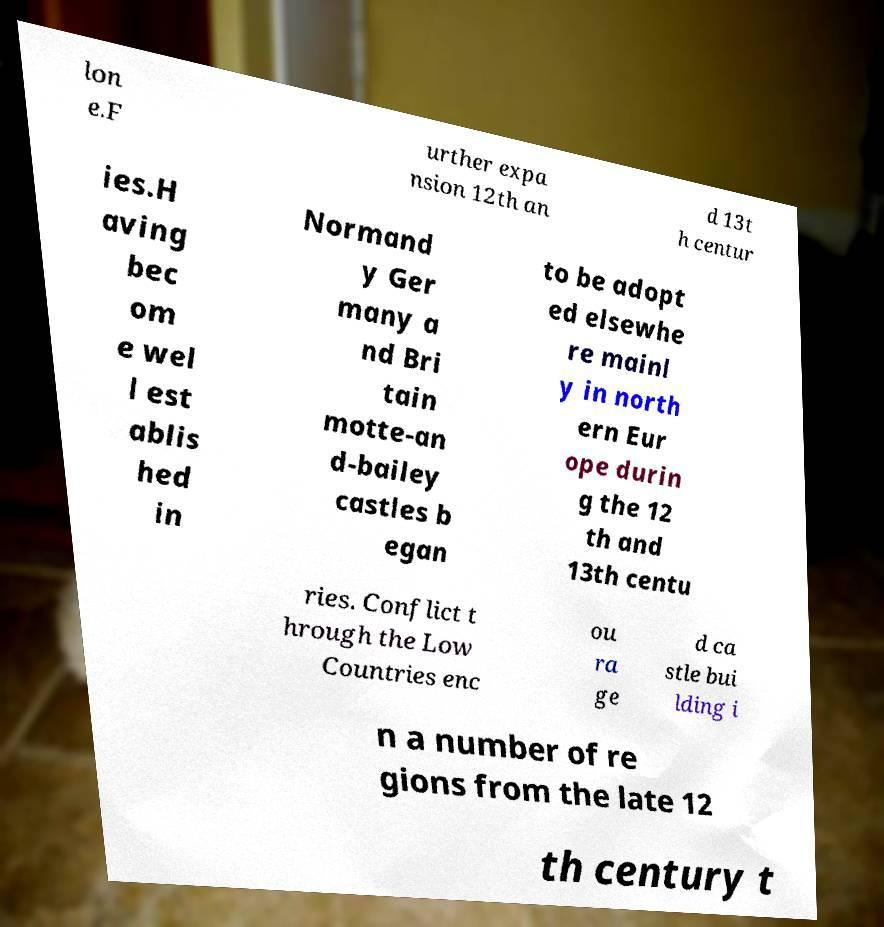Could you extract and type out the text from this image? lon e.F urther expa nsion 12th an d 13t h centur ies.H aving bec om e wel l est ablis hed in Normand y Ger many a nd Bri tain motte-an d-bailey castles b egan to be adopt ed elsewhe re mainl y in north ern Eur ope durin g the 12 th and 13th centu ries. Conflict t hrough the Low Countries enc ou ra ge d ca stle bui lding i n a number of re gions from the late 12 th century t 